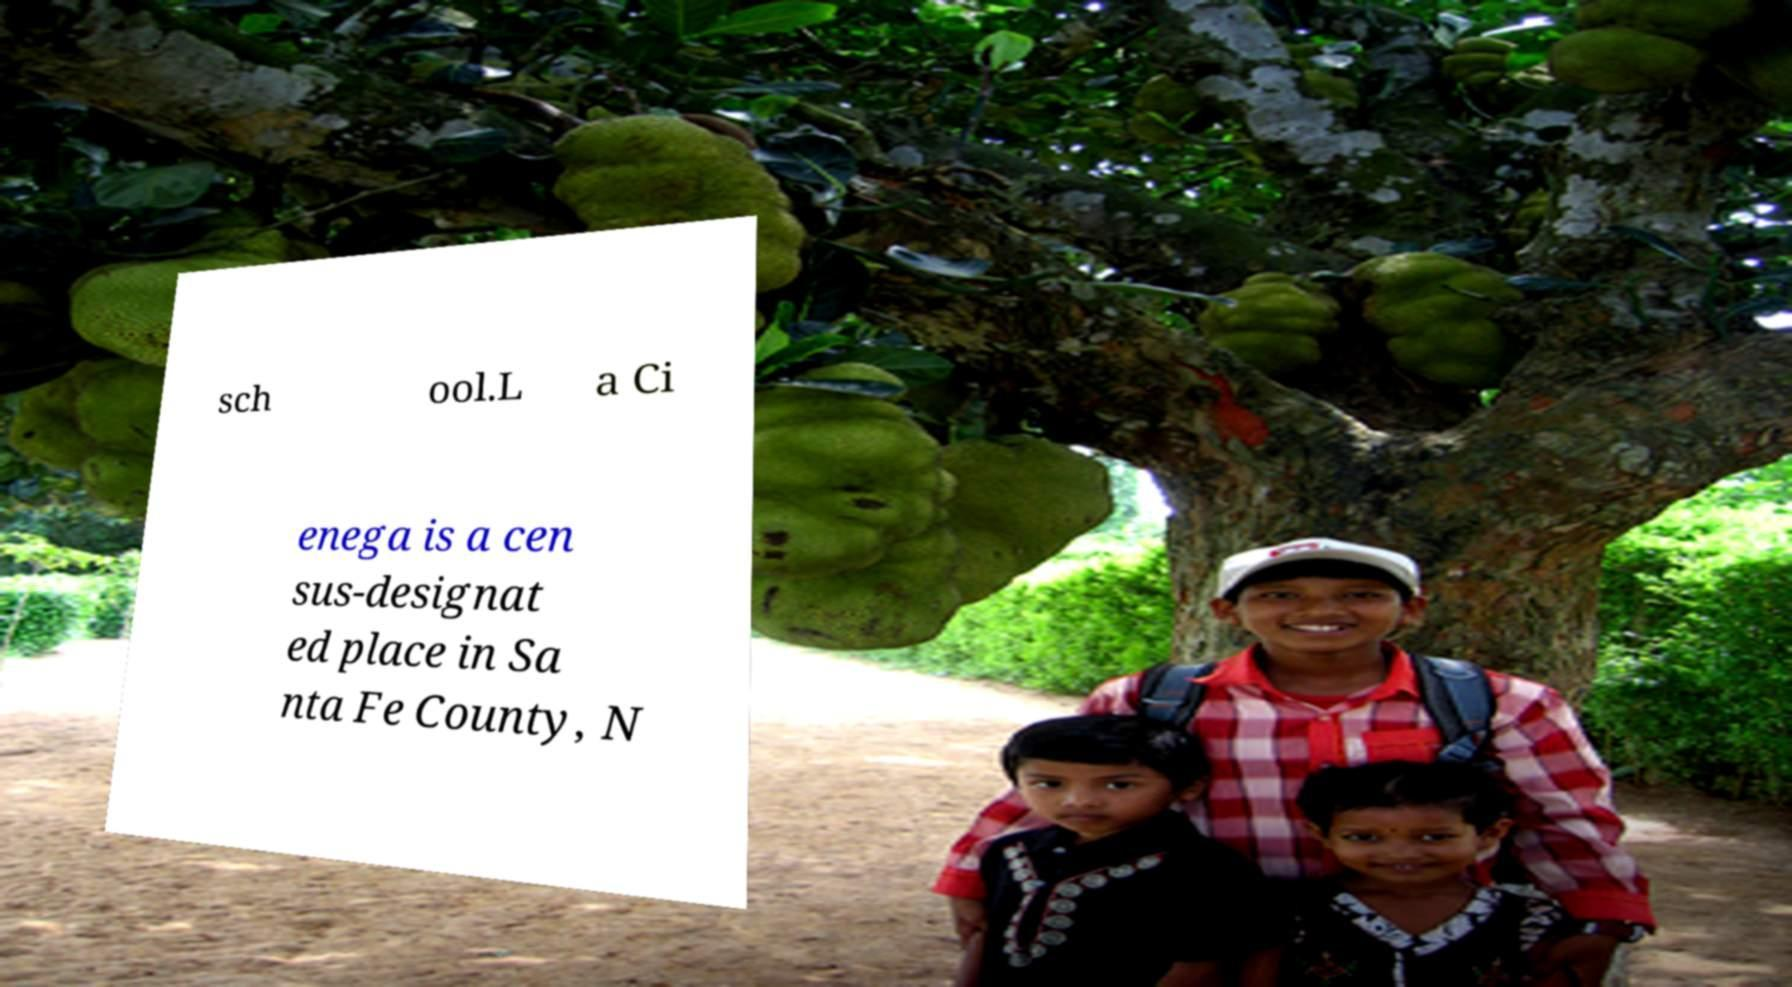Can you accurately transcribe the text from the provided image for me? sch ool.L a Ci enega is a cen sus-designat ed place in Sa nta Fe County, N 